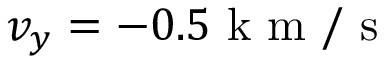Convert formula to latex. <formula><loc_0><loc_0><loc_500><loc_500>v _ { y } = - 0 . 5 k m / s</formula> 